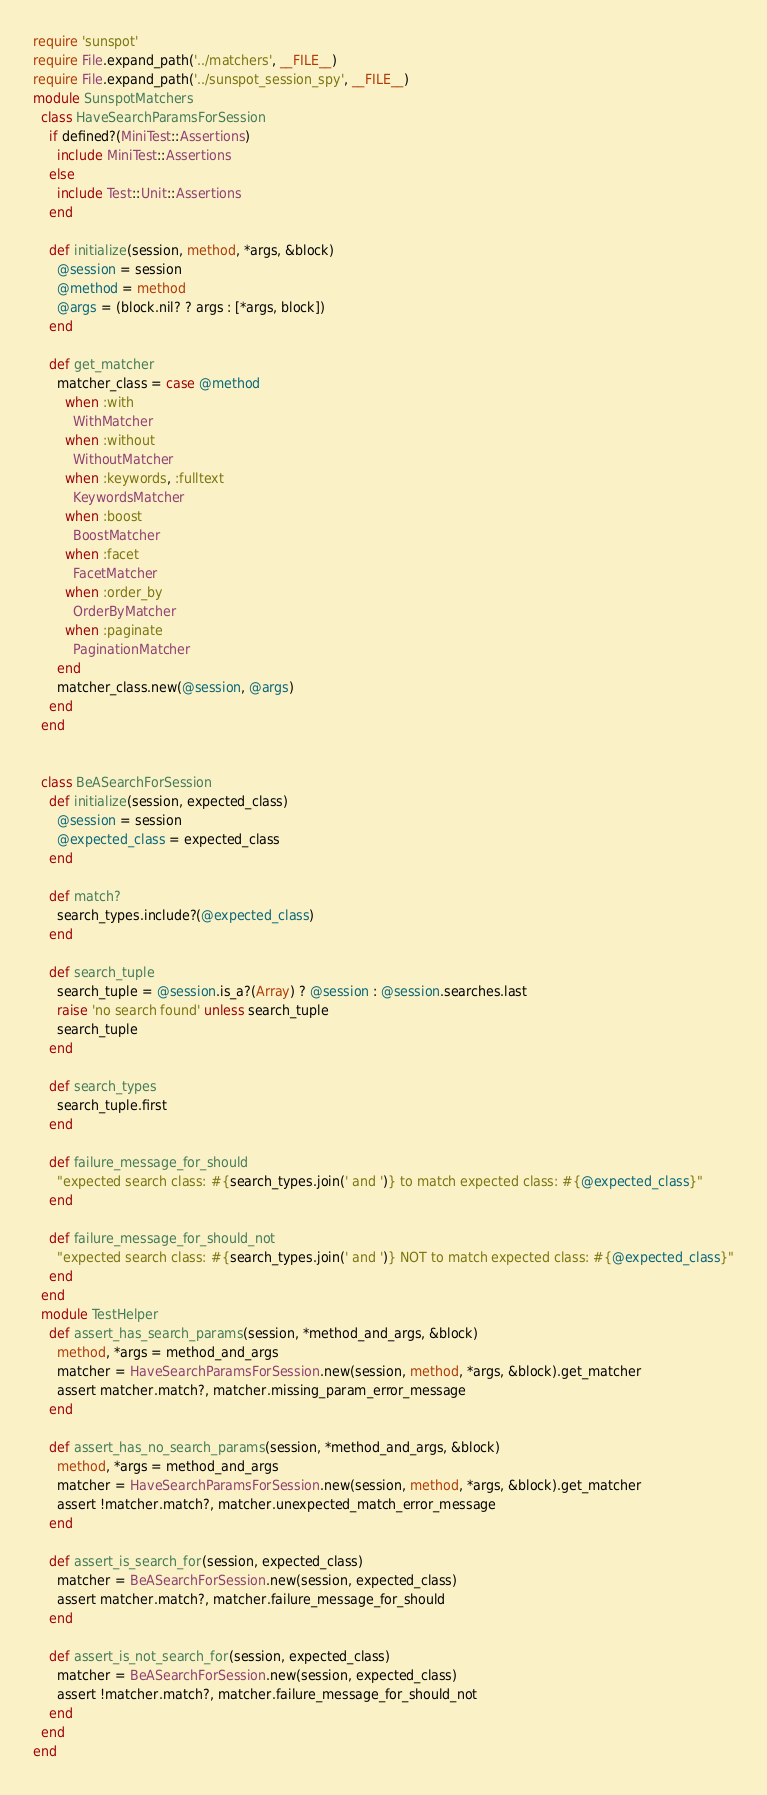<code> <loc_0><loc_0><loc_500><loc_500><_Ruby_>require 'sunspot'
require File.expand_path('../matchers', __FILE__)
require File.expand_path('../sunspot_session_spy', __FILE__)
module SunspotMatchers
  class HaveSearchParamsForSession
    if defined?(MiniTest::Assertions)
      include MiniTest::Assertions
    else
      include Test::Unit::Assertions
    end

    def initialize(session, method, *args, &block)
      @session = session
      @method = method
      @args = (block.nil? ? args : [*args, block])
    end

    def get_matcher
      matcher_class = case @method
        when :with
          WithMatcher
        when :without
          WithoutMatcher
        when :keywords, :fulltext
          KeywordsMatcher
        when :boost
          BoostMatcher
        when :facet
          FacetMatcher
        when :order_by
          OrderByMatcher
        when :paginate
          PaginationMatcher
      end
      matcher_class.new(@session, @args)
    end
  end


  class BeASearchForSession
    def initialize(session, expected_class)
      @session = session
      @expected_class = expected_class
    end

    def match?
      search_types.include?(@expected_class)
    end

    def search_tuple
      search_tuple = @session.is_a?(Array) ? @session : @session.searches.last
      raise 'no search found' unless search_tuple
      search_tuple
    end

    def search_types
      search_tuple.first
    end

    def failure_message_for_should
      "expected search class: #{search_types.join(' and ')} to match expected class: #{@expected_class}"
    end

    def failure_message_for_should_not
      "expected search class: #{search_types.join(' and ')} NOT to match expected class: #{@expected_class}"
    end
  end
  module TestHelper
    def assert_has_search_params(session, *method_and_args, &block)
      method, *args = method_and_args
      matcher = HaveSearchParamsForSession.new(session, method, *args, &block).get_matcher
      assert matcher.match?, matcher.missing_param_error_message
    end

    def assert_has_no_search_params(session, *method_and_args, &block)
      method, *args = method_and_args
      matcher = HaveSearchParamsForSession.new(session, method, *args, &block).get_matcher
      assert !matcher.match?, matcher.unexpected_match_error_message
    end

    def assert_is_search_for(session, expected_class)
      matcher = BeASearchForSession.new(session, expected_class)
      assert matcher.match?, matcher.failure_message_for_should
    end

    def assert_is_not_search_for(session, expected_class)
      matcher = BeASearchForSession.new(session, expected_class)
      assert !matcher.match?, matcher.failure_message_for_should_not
    end
  end
end
</code> 